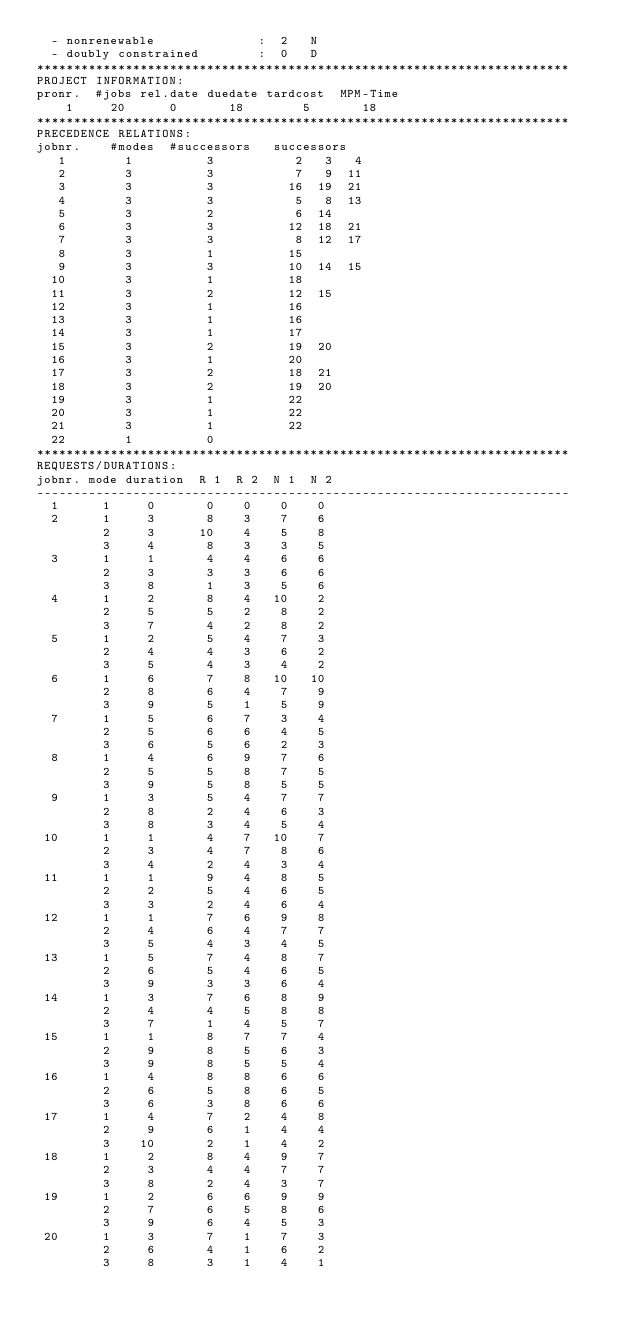<code> <loc_0><loc_0><loc_500><loc_500><_ObjectiveC_>  - nonrenewable              :  2   N
  - doubly constrained        :  0   D
************************************************************************
PROJECT INFORMATION:
pronr.  #jobs rel.date duedate tardcost  MPM-Time
    1     20      0       18        5       18
************************************************************************
PRECEDENCE RELATIONS:
jobnr.    #modes  #successors   successors
   1        1          3           2   3   4
   2        3          3           7   9  11
   3        3          3          16  19  21
   4        3          3           5   8  13
   5        3          2           6  14
   6        3          3          12  18  21
   7        3          3           8  12  17
   8        3          1          15
   9        3          3          10  14  15
  10        3          1          18
  11        3          2          12  15
  12        3          1          16
  13        3          1          16
  14        3          1          17
  15        3          2          19  20
  16        3          1          20
  17        3          2          18  21
  18        3          2          19  20
  19        3          1          22
  20        3          1          22
  21        3          1          22
  22        1          0        
************************************************************************
REQUESTS/DURATIONS:
jobnr. mode duration  R 1  R 2  N 1  N 2
------------------------------------------------------------------------
  1      1     0       0    0    0    0
  2      1     3       8    3    7    6
         2     3      10    4    5    8
         3     4       8    3    3    5
  3      1     1       4    4    6    6
         2     3       3    3    6    6
         3     8       1    3    5    6
  4      1     2       8    4   10    2
         2     5       5    2    8    2
         3     7       4    2    8    2
  5      1     2       5    4    7    3
         2     4       4    3    6    2
         3     5       4    3    4    2
  6      1     6       7    8   10   10
         2     8       6    4    7    9
         3     9       5    1    5    9
  7      1     5       6    7    3    4
         2     5       6    6    4    5
         3     6       5    6    2    3
  8      1     4       6    9    7    6
         2     5       5    8    7    5
         3     9       5    8    5    5
  9      1     3       5    4    7    7
         2     8       2    4    6    3
         3     8       3    4    5    4
 10      1     1       4    7   10    7
         2     3       4    7    8    6
         3     4       2    4    3    4
 11      1     1       9    4    8    5
         2     2       5    4    6    5
         3     3       2    4    6    4
 12      1     1       7    6    9    8
         2     4       6    4    7    7
         3     5       4    3    4    5
 13      1     5       7    4    8    7
         2     6       5    4    6    5
         3     9       3    3    6    4
 14      1     3       7    6    8    9
         2     4       4    5    8    8
         3     7       1    4    5    7
 15      1     1       8    7    7    4
         2     9       8    5    6    3
         3     9       8    5    5    4
 16      1     4       8    8    6    6
         2     6       5    8    6    5
         3     6       3    8    6    6
 17      1     4       7    2    4    8
         2     9       6    1    4    4
         3    10       2    1    4    2
 18      1     2       8    4    9    7
         2     3       4    4    7    7
         3     8       2    4    3    7
 19      1     2       6    6    9    9
         2     7       6    5    8    6
         3     9       6    4    5    3
 20      1     3       7    1    7    3
         2     6       4    1    6    2
         3     8       3    1    4    1</code> 